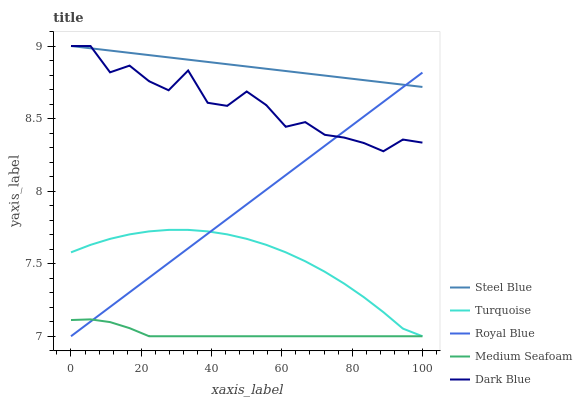Does Medium Seafoam have the minimum area under the curve?
Answer yes or no. Yes. Does Steel Blue have the maximum area under the curve?
Answer yes or no. Yes. Does Turquoise have the minimum area under the curve?
Answer yes or no. No. Does Turquoise have the maximum area under the curve?
Answer yes or no. No. Is Steel Blue the smoothest?
Answer yes or no. Yes. Is Dark Blue the roughest?
Answer yes or no. Yes. Is Turquoise the smoothest?
Answer yes or no. No. Is Turquoise the roughest?
Answer yes or no. No. Does Royal Blue have the lowest value?
Answer yes or no. Yes. Does Steel Blue have the lowest value?
Answer yes or no. No. Does Dark Blue have the highest value?
Answer yes or no. Yes. Does Turquoise have the highest value?
Answer yes or no. No. Is Turquoise less than Steel Blue?
Answer yes or no. Yes. Is Steel Blue greater than Medium Seafoam?
Answer yes or no. Yes. Does Medium Seafoam intersect Turquoise?
Answer yes or no. Yes. Is Medium Seafoam less than Turquoise?
Answer yes or no. No. Is Medium Seafoam greater than Turquoise?
Answer yes or no. No. Does Turquoise intersect Steel Blue?
Answer yes or no. No. 